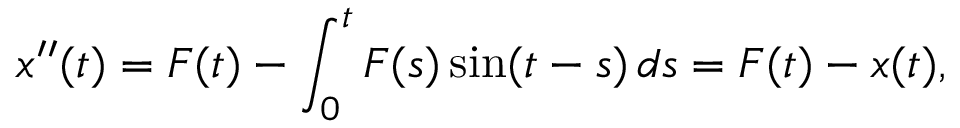Convert formula to latex. <formula><loc_0><loc_0><loc_500><loc_500>x ^ { \prime \prime } ( t ) = F ( t ) - \int _ { 0 } ^ { t } F ( s ) \sin ( t - s ) \, d s = F ( t ) - x ( t ) ,</formula> 